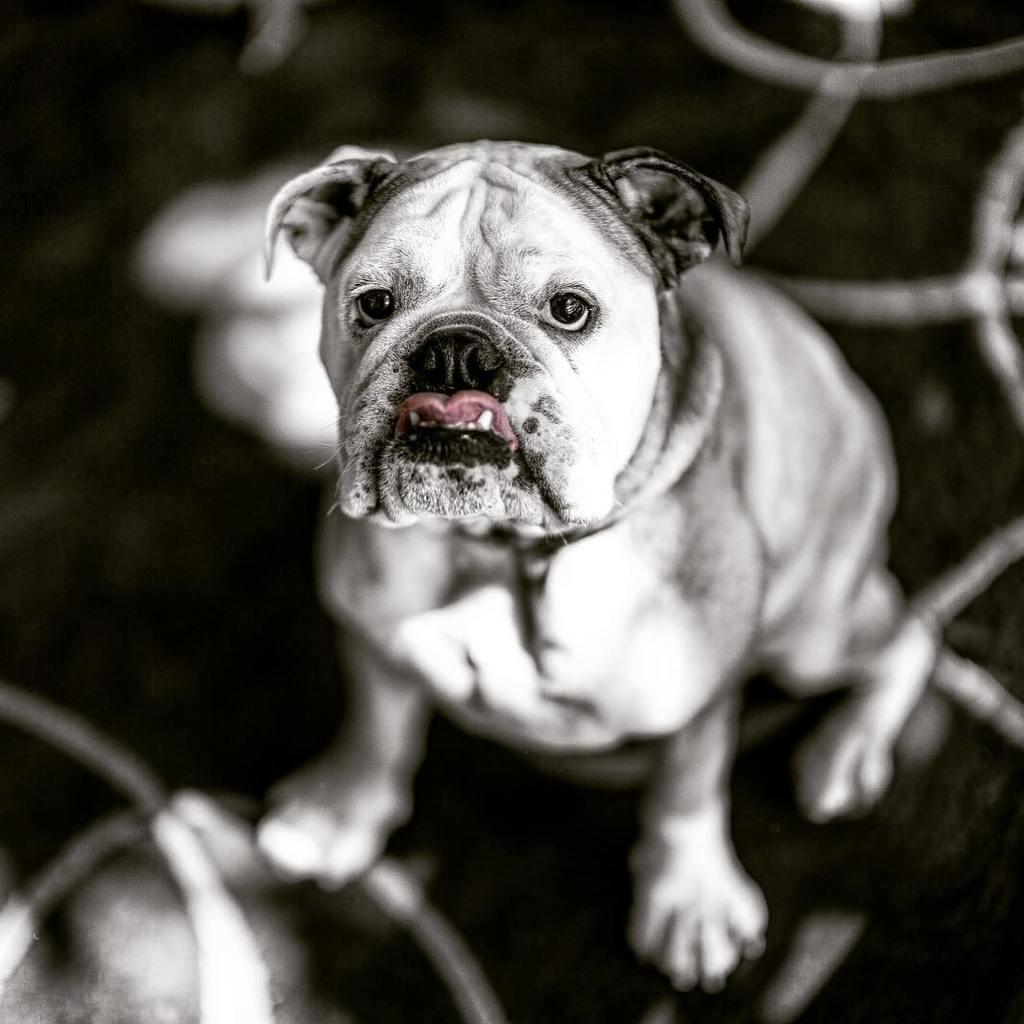What is the main subject of the image? There is a dog in the image. Where is the dog located in the image? The dog is in the center of the image. What colors can be seen on the dog? The dog is white and black in color. Is the dog covered in gold in the image? No, the dog is not covered in gold; it is white and black in color. What class is the dog attending in the image? There is no indication that the dog is attending a class in the image. 